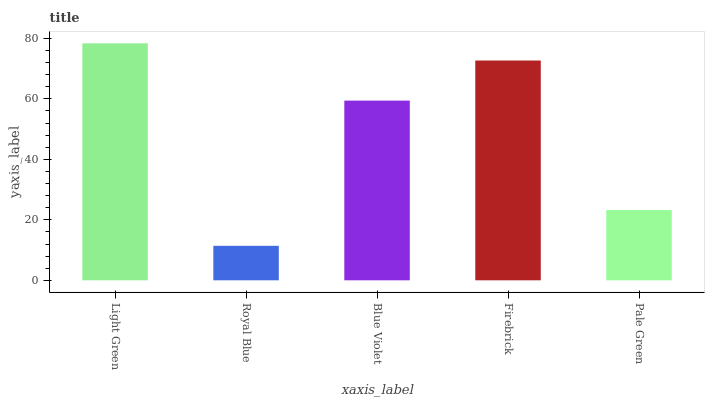Is Royal Blue the minimum?
Answer yes or no. Yes. Is Light Green the maximum?
Answer yes or no. Yes. Is Blue Violet the minimum?
Answer yes or no. No. Is Blue Violet the maximum?
Answer yes or no. No. Is Blue Violet greater than Royal Blue?
Answer yes or no. Yes. Is Royal Blue less than Blue Violet?
Answer yes or no. Yes. Is Royal Blue greater than Blue Violet?
Answer yes or no. No. Is Blue Violet less than Royal Blue?
Answer yes or no. No. Is Blue Violet the high median?
Answer yes or no. Yes. Is Blue Violet the low median?
Answer yes or no. Yes. Is Firebrick the high median?
Answer yes or no. No. Is Pale Green the low median?
Answer yes or no. No. 